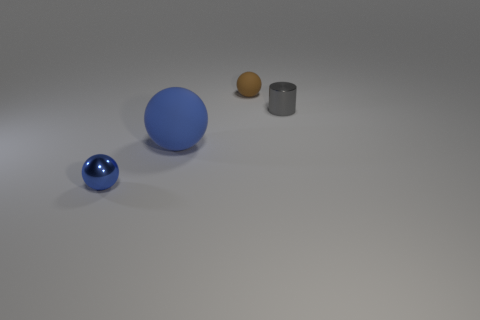Add 2 gray cylinders. How many objects exist? 6 Subtract all spheres. How many objects are left? 1 Add 2 balls. How many balls exist? 5 Subtract 0 red spheres. How many objects are left? 4 Subtract all tiny brown rubber balls. Subtract all tiny things. How many objects are left? 0 Add 3 gray metallic cylinders. How many gray metallic cylinders are left? 4 